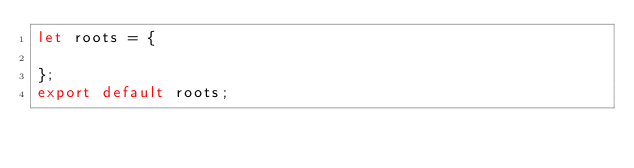<code> <loc_0><loc_0><loc_500><loc_500><_JavaScript_>let roots = {

};
export default roots;</code> 